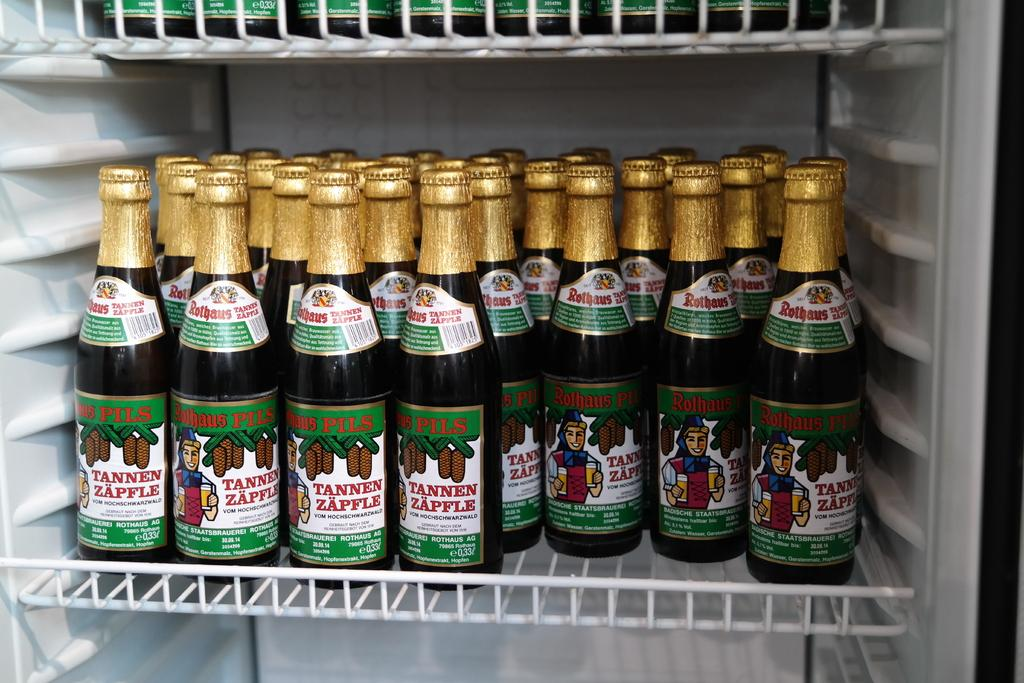<image>
Create a compact narrative representing the image presented. a tannen zapfle that is in a fridge 